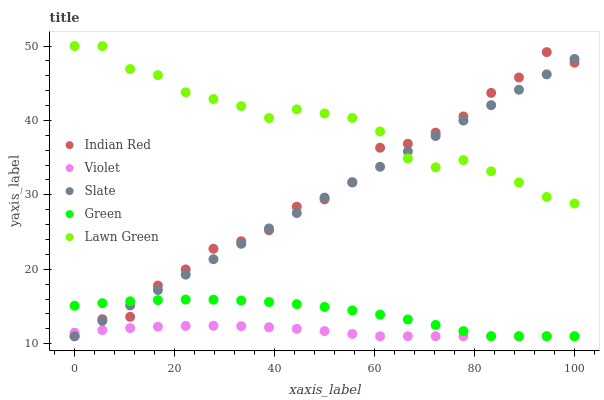Does Violet have the minimum area under the curve?
Answer yes or no. Yes. Does Lawn Green have the maximum area under the curve?
Answer yes or no. Yes. Does Slate have the minimum area under the curve?
Answer yes or no. No. Does Slate have the maximum area under the curve?
Answer yes or no. No. Is Slate the smoothest?
Answer yes or no. Yes. Is Indian Red the roughest?
Answer yes or no. Yes. Is Green the smoothest?
Answer yes or no. No. Is Green the roughest?
Answer yes or no. No. Does Slate have the lowest value?
Answer yes or no. Yes. Does Lawn Green have the highest value?
Answer yes or no. Yes. Does Slate have the highest value?
Answer yes or no. No. Is Violet less than Lawn Green?
Answer yes or no. Yes. Is Lawn Green greater than Violet?
Answer yes or no. Yes. Does Indian Red intersect Lawn Green?
Answer yes or no. Yes. Is Indian Red less than Lawn Green?
Answer yes or no. No. Is Indian Red greater than Lawn Green?
Answer yes or no. No. Does Violet intersect Lawn Green?
Answer yes or no. No. 